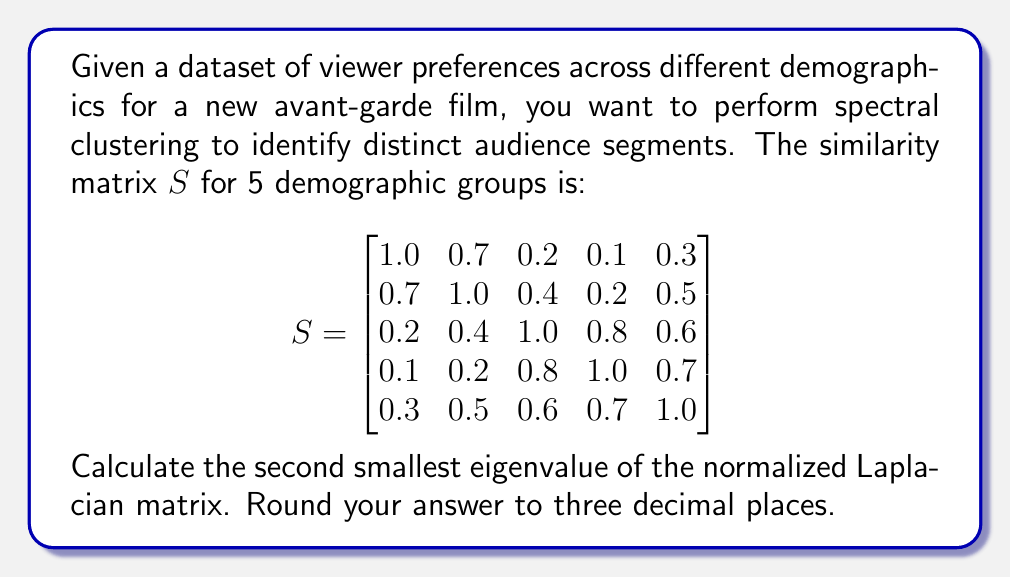Could you help me with this problem? To solve this problem, we'll follow these steps:

1) First, we need to calculate the degree matrix $D$. The degree of each node is the sum of its similarities:

   $$D = \text{diag}(2.3, 2.8, 3.0, 2.8, 3.1)$$

2) Now we can compute the normalized Laplacian matrix $L_{\text{sym}}$:

   $$L_{\text{sym}} = I - D^{-1/2}SD^{-1/2}$$

   Where $I$ is the identity matrix.

3) Expanding this:

   $$L_{\text{sym}} = \begin{bmatrix}
   1 & 0 & 0 & 0 & 0 \\
   0 & 1 & 0 & 0 & 0 \\
   0 & 0 & 1 & 0 & 0 \\
   0 & 0 & 0 & 1 & 0 \\
   0 & 0 & 0 & 0 & 1
   \end{bmatrix} - \begin{bmatrix}
   0.659 & 0.399 & 0.110 & 0.057 & 0.163 \\
   0.399 & 0.597 & 0.220 & 0.114 & 0.271 \\
   0.110 & 0.220 & 0.577 & 0.478 & 0.341 \\
   0.057 & 0.114 & 0.478 & 0.597 & 0.399 \\
   0.163 & 0.271 & 0.341 & 0.399 & 0.568
   \end{bmatrix}$$

4) Resulting in:

   $$L_{\text{sym}} = \begin{bmatrix}
   0.341 & -0.399 & -0.110 & -0.057 & -0.163 \\
   -0.399 & 0.403 & -0.220 & -0.114 & -0.271 \\
   -0.110 & -0.220 & 0.423 & -0.478 & -0.341 \\
   -0.057 & -0.114 & -0.478 & 0.403 & -0.399 \\
   -0.163 & -0.271 & -0.341 & -0.399 & 0.432
   \end{bmatrix}$$

5) We need to find the eigenvalues of this matrix. Using a numerical method (as exact solution would be too complex), we get the eigenvalues:

   $$\lambda_1 \approx 0.000, \lambda_2 \approx 0.249, \lambda_3 \approx 0.391, \lambda_4 \approx 0.631, \lambda_5 \approx 1.729$$

6) The second smallest eigenvalue is $\lambda_2 \approx 0.249$.

Rounding to three decimal places, we get 0.249.
Answer: 0.249 